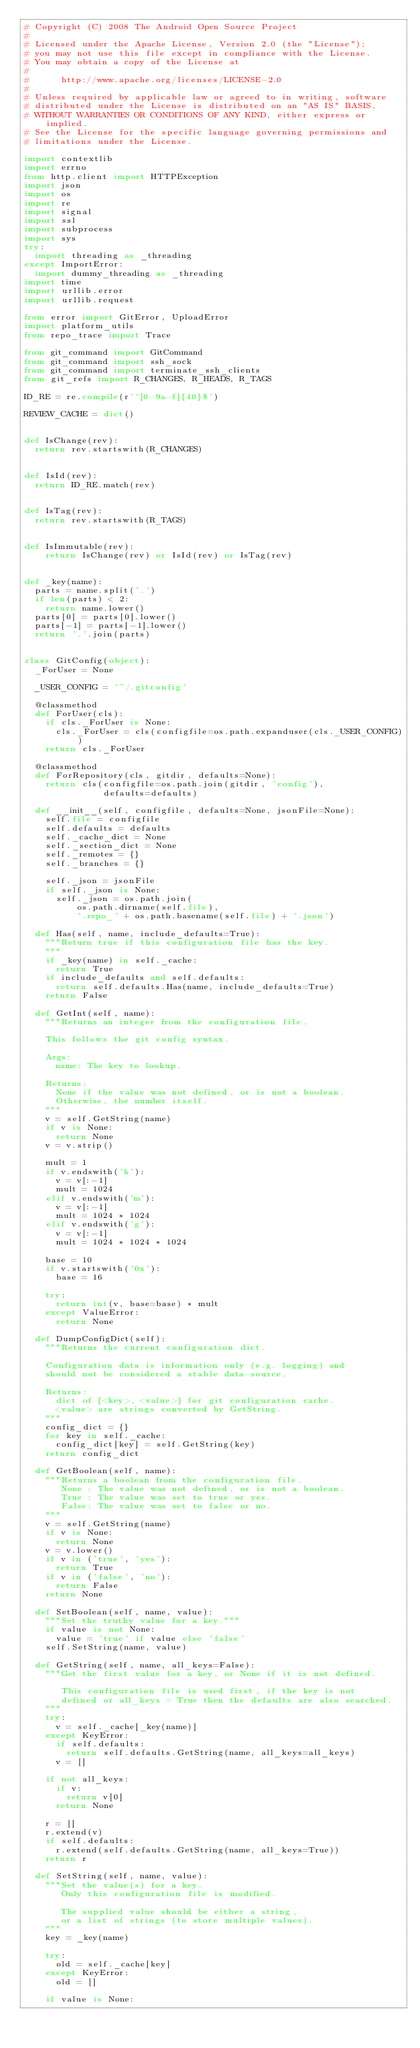<code> <loc_0><loc_0><loc_500><loc_500><_Python_># Copyright (C) 2008 The Android Open Source Project
#
# Licensed under the Apache License, Version 2.0 (the "License");
# you may not use this file except in compliance with the License.
# You may obtain a copy of the License at
#
#      http://www.apache.org/licenses/LICENSE-2.0
#
# Unless required by applicable law or agreed to in writing, software
# distributed under the License is distributed on an "AS IS" BASIS,
# WITHOUT WARRANTIES OR CONDITIONS OF ANY KIND, either express or implied.
# See the License for the specific language governing permissions and
# limitations under the License.

import contextlib
import errno
from http.client import HTTPException
import json
import os
import re
import signal
import ssl
import subprocess
import sys
try:
  import threading as _threading
except ImportError:
  import dummy_threading as _threading
import time
import urllib.error
import urllib.request

from error import GitError, UploadError
import platform_utils
from repo_trace import Trace

from git_command import GitCommand
from git_command import ssh_sock
from git_command import terminate_ssh_clients
from git_refs import R_CHANGES, R_HEADS, R_TAGS

ID_RE = re.compile(r'^[0-9a-f]{40}$')

REVIEW_CACHE = dict()


def IsChange(rev):
  return rev.startswith(R_CHANGES)


def IsId(rev):
  return ID_RE.match(rev)


def IsTag(rev):
  return rev.startswith(R_TAGS)


def IsImmutable(rev):
    return IsChange(rev) or IsId(rev) or IsTag(rev)


def _key(name):
  parts = name.split('.')
  if len(parts) < 2:
    return name.lower()
  parts[0] = parts[0].lower()
  parts[-1] = parts[-1].lower()
  return '.'.join(parts)


class GitConfig(object):
  _ForUser = None

  _USER_CONFIG = '~/.gitconfig'

  @classmethod
  def ForUser(cls):
    if cls._ForUser is None:
      cls._ForUser = cls(configfile=os.path.expanduser(cls._USER_CONFIG))
    return cls._ForUser

  @classmethod
  def ForRepository(cls, gitdir, defaults=None):
    return cls(configfile=os.path.join(gitdir, 'config'),
               defaults=defaults)

  def __init__(self, configfile, defaults=None, jsonFile=None):
    self.file = configfile
    self.defaults = defaults
    self._cache_dict = None
    self._section_dict = None
    self._remotes = {}
    self._branches = {}

    self._json = jsonFile
    if self._json is None:
      self._json = os.path.join(
          os.path.dirname(self.file),
          '.repo_' + os.path.basename(self.file) + '.json')

  def Has(self, name, include_defaults=True):
    """Return true if this configuration file has the key.
    """
    if _key(name) in self._cache:
      return True
    if include_defaults and self.defaults:
      return self.defaults.Has(name, include_defaults=True)
    return False

  def GetInt(self, name):
    """Returns an integer from the configuration file.

    This follows the git config syntax.

    Args:
      name: The key to lookup.

    Returns:
      None if the value was not defined, or is not a boolean.
      Otherwise, the number itself.
    """
    v = self.GetString(name)
    if v is None:
      return None
    v = v.strip()

    mult = 1
    if v.endswith('k'):
      v = v[:-1]
      mult = 1024
    elif v.endswith('m'):
      v = v[:-1]
      mult = 1024 * 1024
    elif v.endswith('g'):
      v = v[:-1]
      mult = 1024 * 1024 * 1024

    base = 10
    if v.startswith('0x'):
      base = 16

    try:
      return int(v, base=base) * mult
    except ValueError:
      return None

  def DumpConfigDict(self):
    """Returns the current configuration dict.

    Configuration data is information only (e.g. logging) and
    should not be considered a stable data-source.

    Returns:
      dict of {<key>, <value>} for git configuration cache.
      <value> are strings converted by GetString.
    """
    config_dict = {}
    for key in self._cache:
      config_dict[key] = self.GetString(key)
    return config_dict

  def GetBoolean(self, name):
    """Returns a boolean from the configuration file.
       None : The value was not defined, or is not a boolean.
       True : The value was set to true or yes.
       False: The value was set to false or no.
    """
    v = self.GetString(name)
    if v is None:
      return None
    v = v.lower()
    if v in ('true', 'yes'):
      return True
    if v in ('false', 'no'):
      return False
    return None

  def SetBoolean(self, name, value):
    """Set the truthy value for a key."""
    if value is not None:
      value = 'true' if value else 'false'
    self.SetString(name, value)

  def GetString(self, name, all_keys=False):
    """Get the first value for a key, or None if it is not defined.

       This configuration file is used first, if the key is not
       defined or all_keys = True then the defaults are also searched.
    """
    try:
      v = self._cache[_key(name)]
    except KeyError:
      if self.defaults:
        return self.defaults.GetString(name, all_keys=all_keys)
      v = []

    if not all_keys:
      if v:
        return v[0]
      return None

    r = []
    r.extend(v)
    if self.defaults:
      r.extend(self.defaults.GetString(name, all_keys=True))
    return r

  def SetString(self, name, value):
    """Set the value(s) for a key.
       Only this configuration file is modified.

       The supplied value should be either a string,
       or a list of strings (to store multiple values).
    """
    key = _key(name)

    try:
      old = self._cache[key]
    except KeyError:
      old = []

    if value is None:</code> 